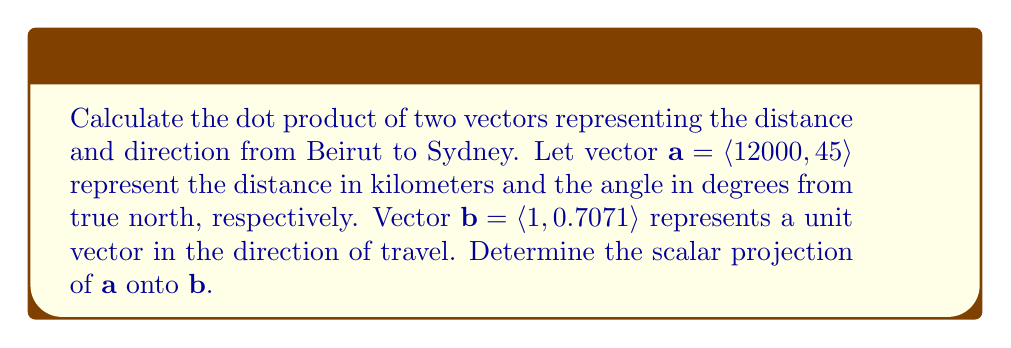Could you help me with this problem? To solve this problem, we'll follow these steps:

1) First, recall the formula for the dot product of two vectors:
   $$\mathbf{a} \cdot \mathbf{b} = a_1b_1 + a_2b_2$$

2) We're given:
   $\mathbf{a} = \langle 12000, 45\rangle$
   $\mathbf{b} = \langle 1, 0.7071\rangle$

3) Let's calculate the dot product:
   $$\mathbf{a} \cdot \mathbf{b} = (12000 \times 1) + (45 \times 0.7071)$$
   $$\mathbf{a} \cdot \mathbf{b} = 12000 + 31.8195$$
   $$\mathbf{a} \cdot \mathbf{b} = 12031.8195$$

4) The scalar projection of $\mathbf{a}$ onto $\mathbf{b}$ is given by:
   $$\text{proj}_\mathbf{b}\mathbf{a} = \frac{\mathbf{a} \cdot \mathbf{b}}{|\mathbf{b}|}$$

5) We need to calculate $|\mathbf{b}|$:
   $$|\mathbf{b}| = \sqrt{1^2 + 0.7071^2} = \sqrt{1.5}$$

6) Now we can calculate the scalar projection:
   $$\text{proj}_\mathbf{b}\mathbf{a} = \frac{12031.8195}{\sqrt{1.5}}$$
   $$\text{proj}_\mathbf{b}\mathbf{a} = 9825.4$$

Therefore, the scalar projection of $\mathbf{a}$ onto $\mathbf{b}$ is approximately 9825.4 km.
Answer: 9825.4 km 